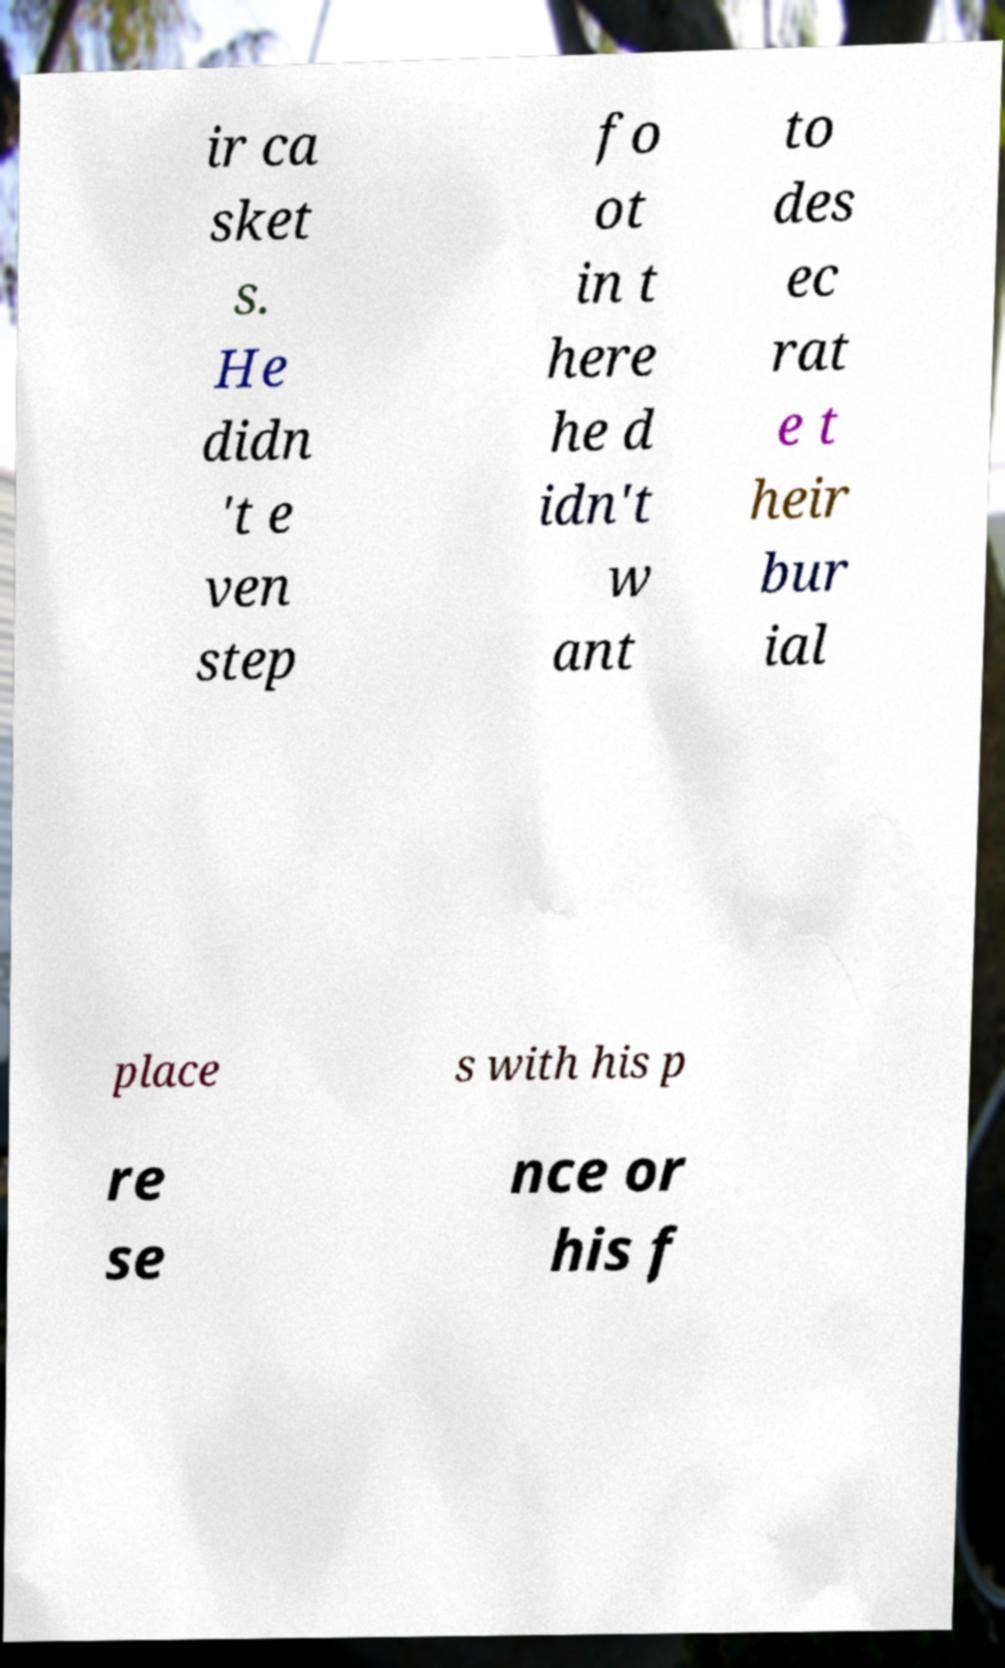There's text embedded in this image that I need extracted. Can you transcribe it verbatim? ir ca sket s. He didn 't e ven step fo ot in t here he d idn't w ant to des ec rat e t heir bur ial place s with his p re se nce or his f 